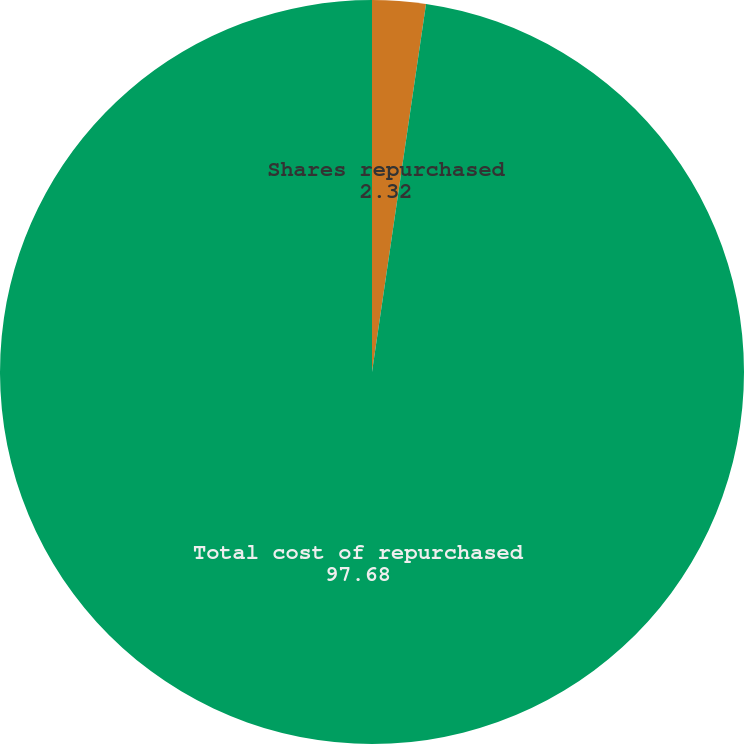<chart> <loc_0><loc_0><loc_500><loc_500><pie_chart><fcel>Shares repurchased<fcel>Total cost of repurchased<nl><fcel>2.32%<fcel>97.68%<nl></chart> 